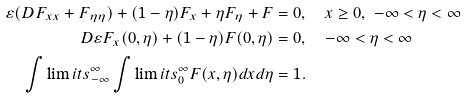<formula> <loc_0><loc_0><loc_500><loc_500>\varepsilon ( D F _ { x x } + F _ { \eta \eta } ) + ( 1 - \eta ) F _ { x } + \eta F _ { \eta } + F & = 0 , \quad x \geq 0 , \ - \infty < \eta < \infty \\ D \varepsilon F _ { x } ( 0 , \eta ) + ( 1 - \eta ) F ( 0 , \eta ) & = 0 , \quad - \infty < \eta < \infty \\ \int \lim i t s _ { - \infty } ^ { \infty } \int \lim i t s _ { 0 } ^ { \infty } F ( x , \eta ) d x d \eta & = 1 .</formula> 